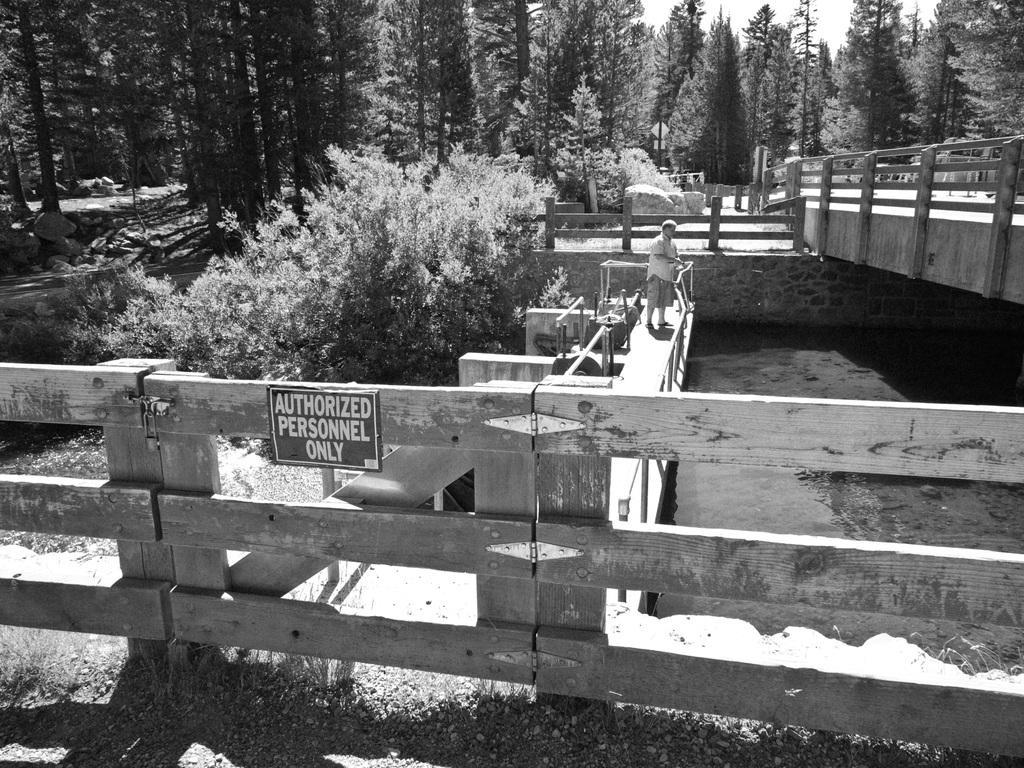Could you give a brief overview of what you see in this image? In this image we can see sky, trees, bushes, wooden fence, water and a person standing on the bridge. 